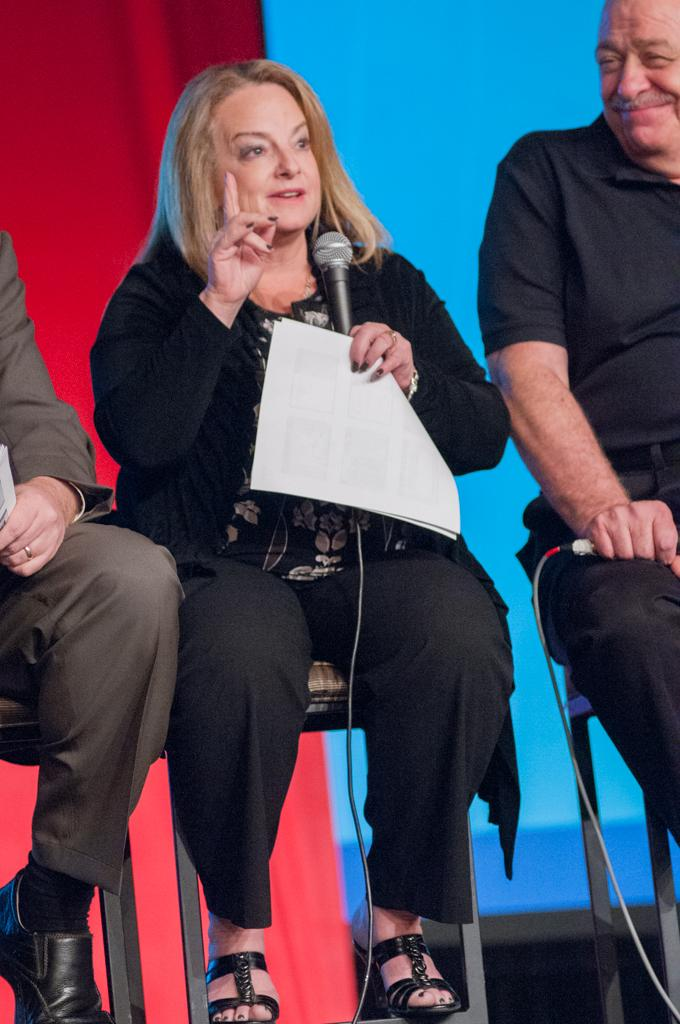How many people are sitting in the image? There are three people sitting on chairs in the image. What is the woman holding in the image? One woman is holding a mic with papers. What can be seen in the background of the image? There is a curtain and a blue color board in the background of the image. How much credit is given to the goose in the image? There is no goose present in the image, so credit cannot be given to a goose. 